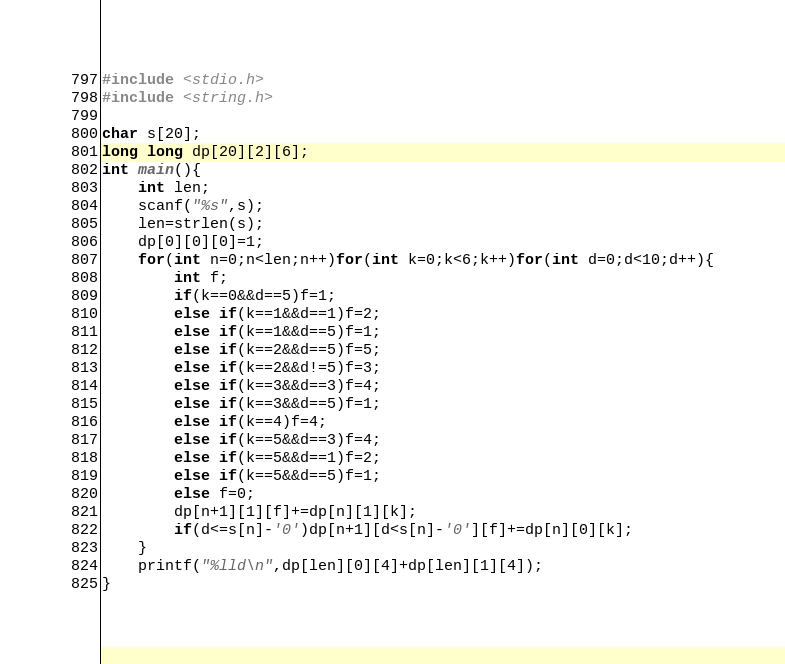Convert code to text. <code><loc_0><loc_0><loc_500><loc_500><_C_>#include <stdio.h>
#include <string.h>

char s[20];
long long dp[20][2][6];
int main(){
	int len;
	scanf("%s",s);
	len=strlen(s);
	dp[0][0][0]=1;
	for(int n=0;n<len;n++)for(int k=0;k<6;k++)for(int d=0;d<10;d++){
		int f;
		if(k==0&&d==5)f=1;
		else if(k==1&&d==1)f=2;
		else if(k==1&&d==5)f=1;
		else if(k==2&&d==5)f=5;
		else if(k==2&&d!=5)f=3;
		else if(k==3&&d==3)f=4;
		else if(k==3&&d==5)f=1;
		else if(k==4)f=4;
		else if(k==5&&d==3)f=4;
		else if(k==5&&d==1)f=2;
		else if(k==5&&d==5)f=1;
		else f=0;
		dp[n+1][1][f]+=dp[n][1][k];
		if(d<=s[n]-'0')dp[n+1][d<s[n]-'0'][f]+=dp[n][0][k];
	}
	printf("%lld\n",dp[len][0][4]+dp[len][1][4]);
}
</code> 